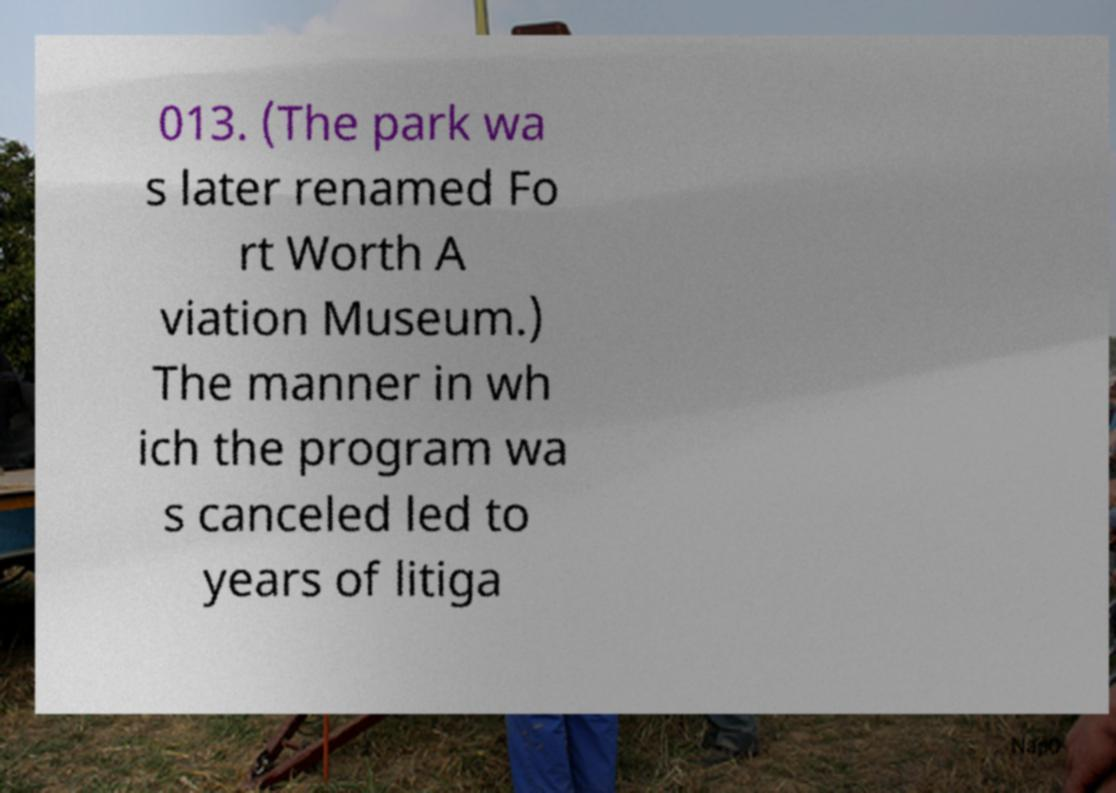Please read and relay the text visible in this image. What does it say? 013. (The park wa s later renamed Fo rt Worth A viation Museum.) The manner in wh ich the program wa s canceled led to years of litiga 